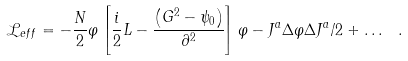<formula> <loc_0><loc_0><loc_500><loc_500>\mathcal { L } _ { e f f } = - \frac { N } { 2 } \varphi \left [ \frac { i } { 2 } L - \frac { \left ( G ^ { 2 } - \psi _ { 0 } \right ) } { \partial ^ { 2 } } \right ] \varphi - J ^ { a } \Delta \varphi \Delta J ^ { a } / 2 + \dots \ .</formula> 